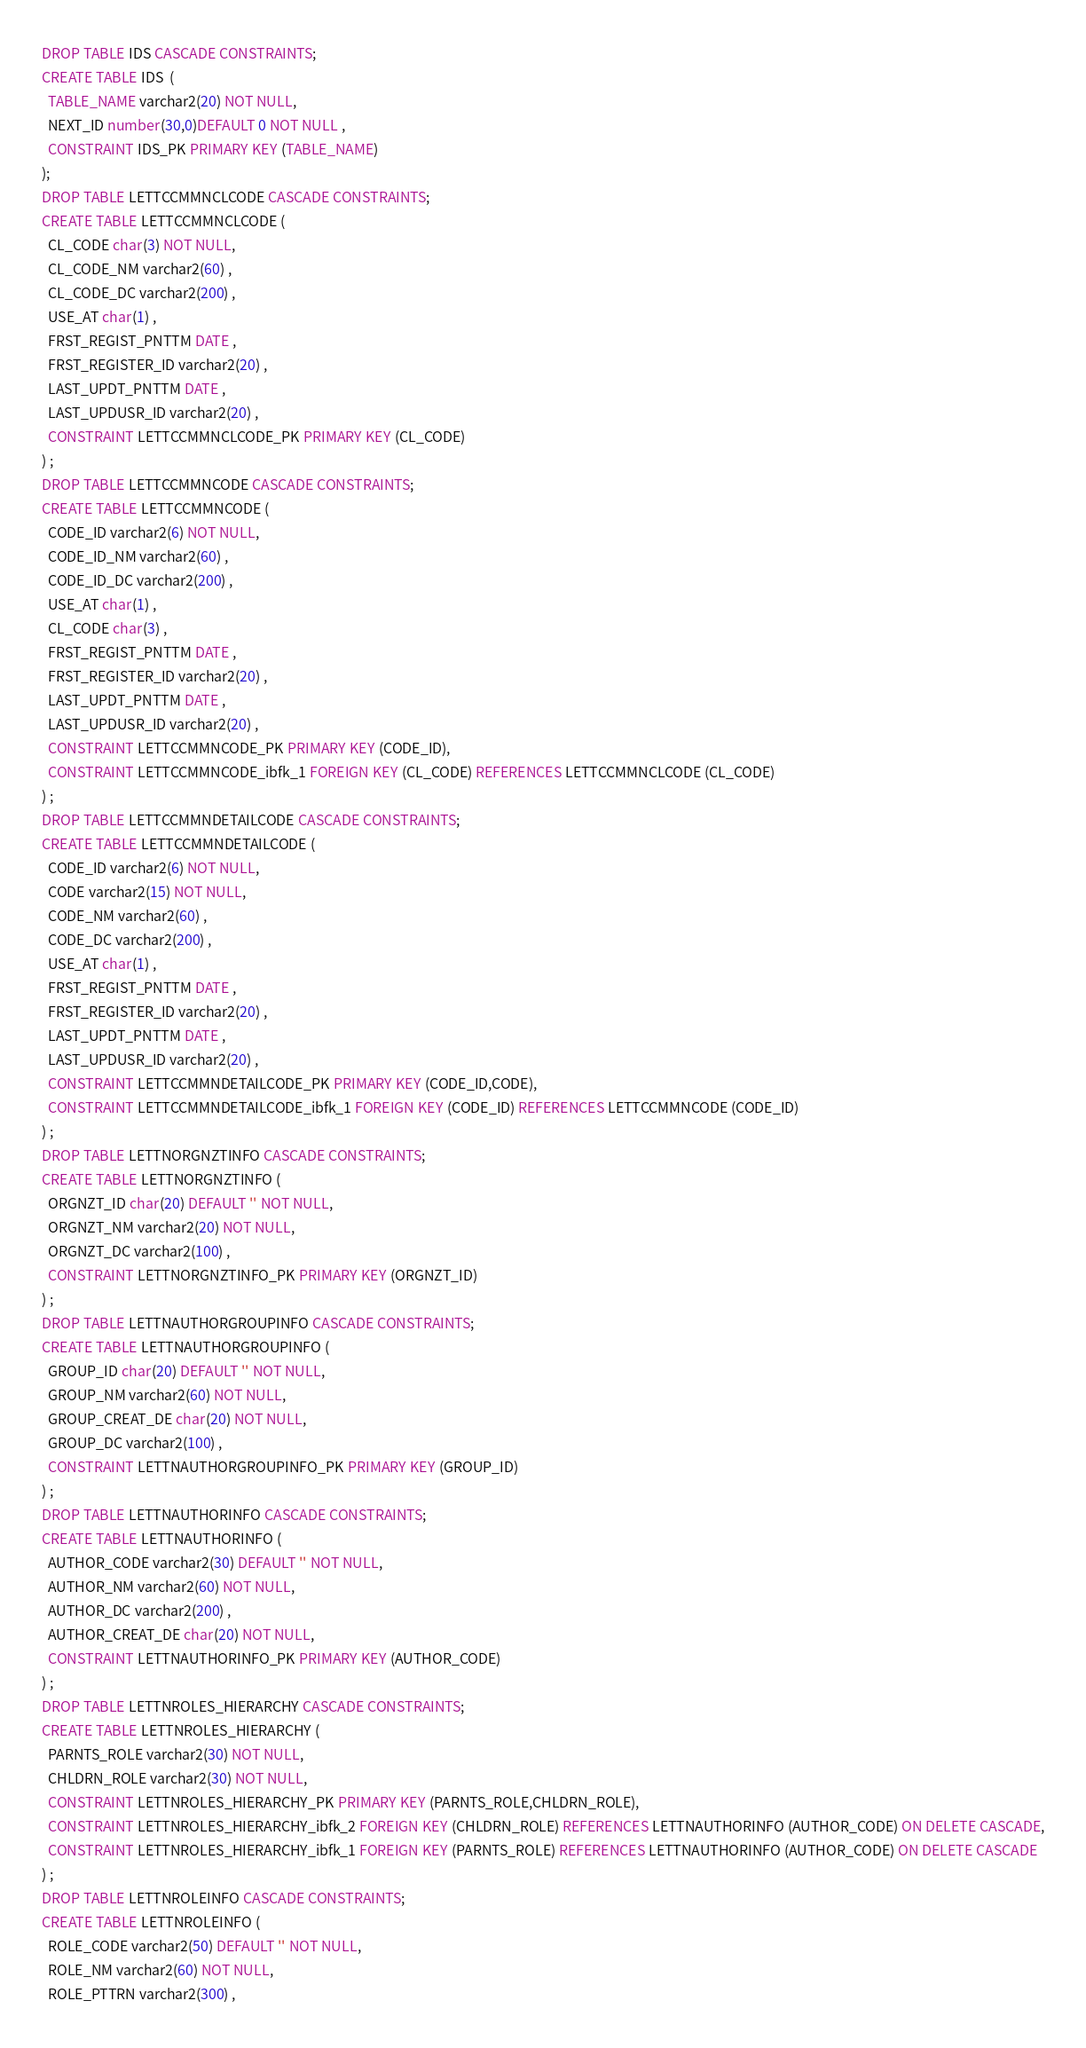Convert code to text. <code><loc_0><loc_0><loc_500><loc_500><_SQL_>DROP TABLE IDS CASCADE CONSTRAINTS;
CREATE TABLE IDS  (
  TABLE_NAME varchar2(20) NOT NULL,
  NEXT_ID number(30,0)DEFAULT 0 NOT NULL ,
  CONSTRAINT IDS_PK PRIMARY KEY (TABLE_NAME)
);
DROP TABLE LETTCCMMNCLCODE CASCADE CONSTRAINTS;
CREATE TABLE LETTCCMMNCLCODE (
  CL_CODE char(3) NOT NULL,
  CL_CODE_NM varchar2(60) ,
  CL_CODE_DC varchar2(200) ,
  USE_AT char(1) ,
  FRST_REGIST_PNTTM DATE ,
  FRST_REGISTER_ID varchar2(20) ,
  LAST_UPDT_PNTTM DATE ,
  LAST_UPDUSR_ID varchar2(20) ,
  CONSTRAINT LETTCCMMNCLCODE_PK PRIMARY KEY (CL_CODE)
) ;
DROP TABLE LETTCCMMNCODE CASCADE CONSTRAINTS;
CREATE TABLE LETTCCMMNCODE (
  CODE_ID varchar2(6) NOT NULL,
  CODE_ID_NM varchar2(60) ,
  CODE_ID_DC varchar2(200) ,
  USE_AT char(1) ,
  CL_CODE char(3) ,
  FRST_REGIST_PNTTM DATE ,
  FRST_REGISTER_ID varchar2(20) ,
  LAST_UPDT_PNTTM DATE ,
  LAST_UPDUSR_ID varchar2(20) ,
  CONSTRAINT LETTCCMMNCODE_PK PRIMARY KEY (CODE_ID),
  CONSTRAINT LETTCCMMNCODE_ibfk_1 FOREIGN KEY (CL_CODE) REFERENCES LETTCCMMNCLCODE (CL_CODE)
) ;
DROP TABLE LETTCCMMNDETAILCODE CASCADE CONSTRAINTS;
CREATE TABLE LETTCCMMNDETAILCODE (
  CODE_ID varchar2(6) NOT NULL,
  CODE varchar2(15) NOT NULL,
  CODE_NM varchar2(60) ,
  CODE_DC varchar2(200) ,
  USE_AT char(1) ,
  FRST_REGIST_PNTTM DATE ,
  FRST_REGISTER_ID varchar2(20) ,
  LAST_UPDT_PNTTM DATE ,
  LAST_UPDUSR_ID varchar2(20) ,
  CONSTRAINT LETTCCMMNDETAILCODE_PK PRIMARY KEY (CODE_ID,CODE),
  CONSTRAINT LETTCCMMNDETAILCODE_ibfk_1 FOREIGN KEY (CODE_ID) REFERENCES LETTCCMMNCODE (CODE_ID)
) ;
DROP TABLE LETTNORGNZTINFO CASCADE CONSTRAINTS;
CREATE TABLE LETTNORGNZTINFO (
  ORGNZT_ID char(20) DEFAULT '' NOT NULL,
  ORGNZT_NM varchar2(20) NOT NULL,
  ORGNZT_DC varchar2(100) ,
  CONSTRAINT LETTNORGNZTINFO_PK PRIMARY KEY (ORGNZT_ID)
) ;
DROP TABLE LETTNAUTHORGROUPINFO CASCADE CONSTRAINTS;
CREATE TABLE LETTNAUTHORGROUPINFO (
  GROUP_ID char(20) DEFAULT '' NOT NULL,
  GROUP_NM varchar2(60) NOT NULL,
  GROUP_CREAT_DE char(20) NOT NULL,
  GROUP_DC varchar2(100) ,
  CONSTRAINT LETTNAUTHORGROUPINFO_PK PRIMARY KEY (GROUP_ID)
) ;
DROP TABLE LETTNAUTHORINFO CASCADE CONSTRAINTS;
CREATE TABLE LETTNAUTHORINFO (
  AUTHOR_CODE varchar2(30) DEFAULT '' NOT NULL,
  AUTHOR_NM varchar2(60) NOT NULL,
  AUTHOR_DC varchar2(200) ,
  AUTHOR_CREAT_DE char(20) NOT NULL,
  CONSTRAINT LETTNAUTHORINFO_PK PRIMARY KEY (AUTHOR_CODE)
) ;
DROP TABLE LETTNROLES_HIERARCHY CASCADE CONSTRAINTS;
CREATE TABLE LETTNROLES_HIERARCHY (
  PARNTS_ROLE varchar2(30) NOT NULL,
  CHLDRN_ROLE varchar2(30) NOT NULL,
  CONSTRAINT LETTNROLES_HIERARCHY_PK PRIMARY KEY (PARNTS_ROLE,CHLDRN_ROLE),
  CONSTRAINT LETTNROLES_HIERARCHY_ibfk_2 FOREIGN KEY (CHLDRN_ROLE) REFERENCES LETTNAUTHORINFO (AUTHOR_CODE) ON DELETE CASCADE,
  CONSTRAINT LETTNROLES_HIERARCHY_ibfk_1 FOREIGN KEY (PARNTS_ROLE) REFERENCES LETTNAUTHORINFO (AUTHOR_CODE) ON DELETE CASCADE
) ;
DROP TABLE LETTNROLEINFO CASCADE CONSTRAINTS;
CREATE TABLE LETTNROLEINFO (
  ROLE_CODE varchar2(50) DEFAULT '' NOT NULL,
  ROLE_NM varchar2(60) NOT NULL,
  ROLE_PTTRN varchar2(300) ,</code> 